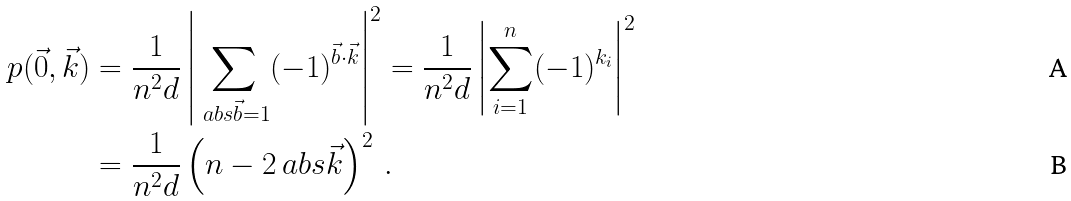Convert formula to latex. <formula><loc_0><loc_0><loc_500><loc_500>p ( \vec { 0 } , \vec { k } ) & = \frac { 1 } { n ^ { 2 } d } \left | \sum _ { \ a b s { \vec { b } } = 1 } ( - 1 ) ^ { \vec { b } \cdot \vec { k } } \right | ^ { 2 } = \frac { 1 } { n ^ { 2 } d } \left | \sum _ { i = 1 } ^ { n } ( - 1 ) ^ { k _ { i } } \right | ^ { 2 } \\ & = \frac { 1 } { n ^ { 2 } d } \left ( n - 2 \ a b s { \vec { k } } \right ) ^ { 2 } \, .</formula> 